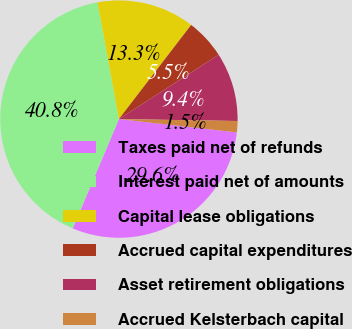Convert chart. <chart><loc_0><loc_0><loc_500><loc_500><pie_chart><fcel>Taxes paid net of refunds<fcel>Interest paid net of amounts<fcel>Capital lease obligations<fcel>Accrued capital expenditures<fcel>Asset retirement obligations<fcel>Accrued Kelsterbach capital<nl><fcel>29.58%<fcel>40.75%<fcel>13.3%<fcel>5.46%<fcel>9.38%<fcel>1.53%<nl></chart> 